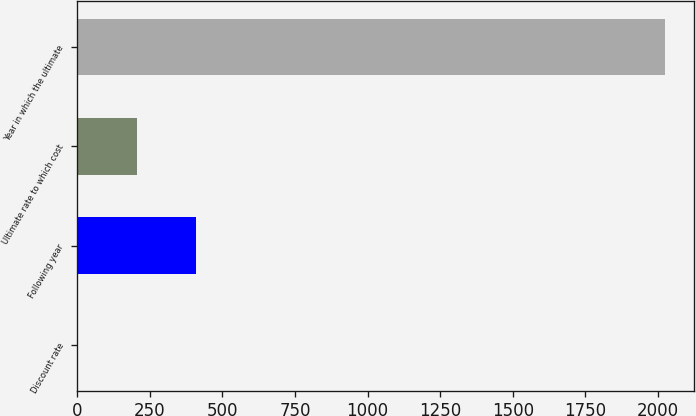Convert chart to OTSL. <chart><loc_0><loc_0><loc_500><loc_500><bar_chart><fcel>Discount rate<fcel>Following year<fcel>Ultimate rate to which cost<fcel>Year in which the ultimate<nl><fcel>3.2<fcel>407.16<fcel>205.18<fcel>2023<nl></chart> 